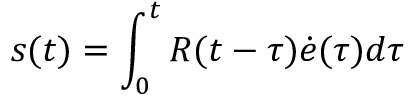Convert formula to latex. <formula><loc_0><loc_0><loc_500><loc_500>s ( t ) = \int _ { 0 } ^ { t } R ( t - \tau ) \dot { e } ( \tau ) d \tau</formula> 